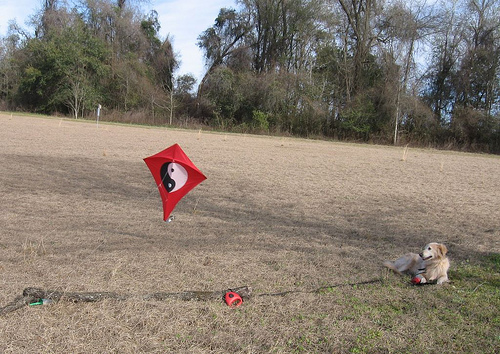<image>What symbol is on the kite? I am not sure what symbol is on the kite. It can be either 'yin yang' or 'ying yang'. What symbol is on the kite? I am not sure what symbol is on the kite. It can be seen 'ying&yang', 'yin yang', or 'peace'. 